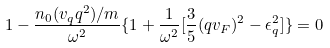<formula> <loc_0><loc_0><loc_500><loc_500>1 - \frac { n _ { 0 } ( v _ { q } q ^ { 2 } ) / m } { \omega ^ { 2 } } \{ 1 + \frac { 1 } { \omega ^ { 2 } } [ \frac { 3 } { 5 } ( q v _ { F } ) ^ { 2 } - \epsilon ^ { 2 } _ { q } ] \} = 0</formula> 